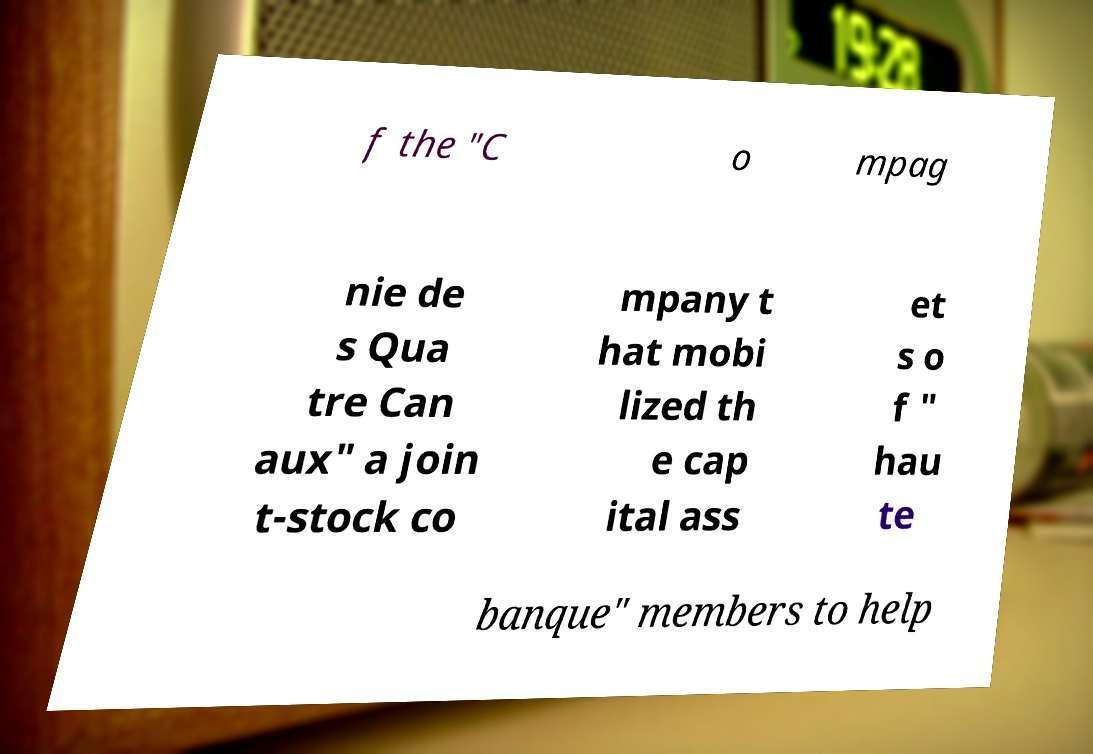There's text embedded in this image that I need extracted. Can you transcribe it verbatim? f the "C o mpag nie de s Qua tre Can aux" a join t-stock co mpany t hat mobi lized th e cap ital ass et s o f " hau te banque" members to help 